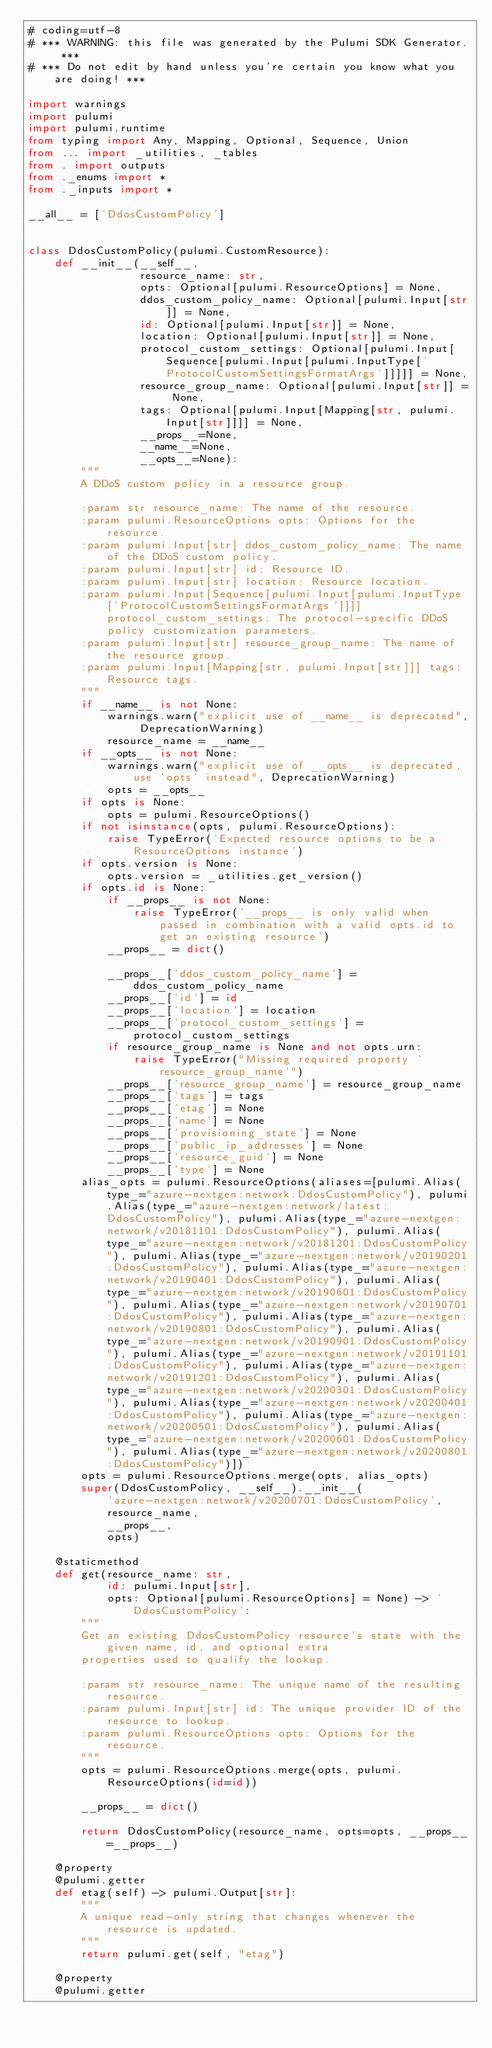Convert code to text. <code><loc_0><loc_0><loc_500><loc_500><_Python_># coding=utf-8
# *** WARNING: this file was generated by the Pulumi SDK Generator. ***
# *** Do not edit by hand unless you're certain you know what you are doing! ***

import warnings
import pulumi
import pulumi.runtime
from typing import Any, Mapping, Optional, Sequence, Union
from ... import _utilities, _tables
from . import outputs
from ._enums import *
from ._inputs import *

__all__ = ['DdosCustomPolicy']


class DdosCustomPolicy(pulumi.CustomResource):
    def __init__(__self__,
                 resource_name: str,
                 opts: Optional[pulumi.ResourceOptions] = None,
                 ddos_custom_policy_name: Optional[pulumi.Input[str]] = None,
                 id: Optional[pulumi.Input[str]] = None,
                 location: Optional[pulumi.Input[str]] = None,
                 protocol_custom_settings: Optional[pulumi.Input[Sequence[pulumi.Input[pulumi.InputType['ProtocolCustomSettingsFormatArgs']]]]] = None,
                 resource_group_name: Optional[pulumi.Input[str]] = None,
                 tags: Optional[pulumi.Input[Mapping[str, pulumi.Input[str]]]] = None,
                 __props__=None,
                 __name__=None,
                 __opts__=None):
        """
        A DDoS custom policy in a resource group.

        :param str resource_name: The name of the resource.
        :param pulumi.ResourceOptions opts: Options for the resource.
        :param pulumi.Input[str] ddos_custom_policy_name: The name of the DDoS custom policy.
        :param pulumi.Input[str] id: Resource ID.
        :param pulumi.Input[str] location: Resource location.
        :param pulumi.Input[Sequence[pulumi.Input[pulumi.InputType['ProtocolCustomSettingsFormatArgs']]]] protocol_custom_settings: The protocol-specific DDoS policy customization parameters.
        :param pulumi.Input[str] resource_group_name: The name of the resource group.
        :param pulumi.Input[Mapping[str, pulumi.Input[str]]] tags: Resource tags.
        """
        if __name__ is not None:
            warnings.warn("explicit use of __name__ is deprecated", DeprecationWarning)
            resource_name = __name__
        if __opts__ is not None:
            warnings.warn("explicit use of __opts__ is deprecated, use 'opts' instead", DeprecationWarning)
            opts = __opts__
        if opts is None:
            opts = pulumi.ResourceOptions()
        if not isinstance(opts, pulumi.ResourceOptions):
            raise TypeError('Expected resource options to be a ResourceOptions instance')
        if opts.version is None:
            opts.version = _utilities.get_version()
        if opts.id is None:
            if __props__ is not None:
                raise TypeError('__props__ is only valid when passed in combination with a valid opts.id to get an existing resource')
            __props__ = dict()

            __props__['ddos_custom_policy_name'] = ddos_custom_policy_name
            __props__['id'] = id
            __props__['location'] = location
            __props__['protocol_custom_settings'] = protocol_custom_settings
            if resource_group_name is None and not opts.urn:
                raise TypeError("Missing required property 'resource_group_name'")
            __props__['resource_group_name'] = resource_group_name
            __props__['tags'] = tags
            __props__['etag'] = None
            __props__['name'] = None
            __props__['provisioning_state'] = None
            __props__['public_ip_addresses'] = None
            __props__['resource_guid'] = None
            __props__['type'] = None
        alias_opts = pulumi.ResourceOptions(aliases=[pulumi.Alias(type_="azure-nextgen:network:DdosCustomPolicy"), pulumi.Alias(type_="azure-nextgen:network/latest:DdosCustomPolicy"), pulumi.Alias(type_="azure-nextgen:network/v20181101:DdosCustomPolicy"), pulumi.Alias(type_="azure-nextgen:network/v20181201:DdosCustomPolicy"), pulumi.Alias(type_="azure-nextgen:network/v20190201:DdosCustomPolicy"), pulumi.Alias(type_="azure-nextgen:network/v20190401:DdosCustomPolicy"), pulumi.Alias(type_="azure-nextgen:network/v20190601:DdosCustomPolicy"), pulumi.Alias(type_="azure-nextgen:network/v20190701:DdosCustomPolicy"), pulumi.Alias(type_="azure-nextgen:network/v20190801:DdosCustomPolicy"), pulumi.Alias(type_="azure-nextgen:network/v20190901:DdosCustomPolicy"), pulumi.Alias(type_="azure-nextgen:network/v20191101:DdosCustomPolicy"), pulumi.Alias(type_="azure-nextgen:network/v20191201:DdosCustomPolicy"), pulumi.Alias(type_="azure-nextgen:network/v20200301:DdosCustomPolicy"), pulumi.Alias(type_="azure-nextgen:network/v20200401:DdosCustomPolicy"), pulumi.Alias(type_="azure-nextgen:network/v20200501:DdosCustomPolicy"), pulumi.Alias(type_="azure-nextgen:network/v20200601:DdosCustomPolicy"), pulumi.Alias(type_="azure-nextgen:network/v20200801:DdosCustomPolicy")])
        opts = pulumi.ResourceOptions.merge(opts, alias_opts)
        super(DdosCustomPolicy, __self__).__init__(
            'azure-nextgen:network/v20200701:DdosCustomPolicy',
            resource_name,
            __props__,
            opts)

    @staticmethod
    def get(resource_name: str,
            id: pulumi.Input[str],
            opts: Optional[pulumi.ResourceOptions] = None) -> 'DdosCustomPolicy':
        """
        Get an existing DdosCustomPolicy resource's state with the given name, id, and optional extra
        properties used to qualify the lookup.

        :param str resource_name: The unique name of the resulting resource.
        :param pulumi.Input[str] id: The unique provider ID of the resource to lookup.
        :param pulumi.ResourceOptions opts: Options for the resource.
        """
        opts = pulumi.ResourceOptions.merge(opts, pulumi.ResourceOptions(id=id))

        __props__ = dict()

        return DdosCustomPolicy(resource_name, opts=opts, __props__=__props__)

    @property
    @pulumi.getter
    def etag(self) -> pulumi.Output[str]:
        """
        A unique read-only string that changes whenever the resource is updated.
        """
        return pulumi.get(self, "etag")

    @property
    @pulumi.getter</code> 